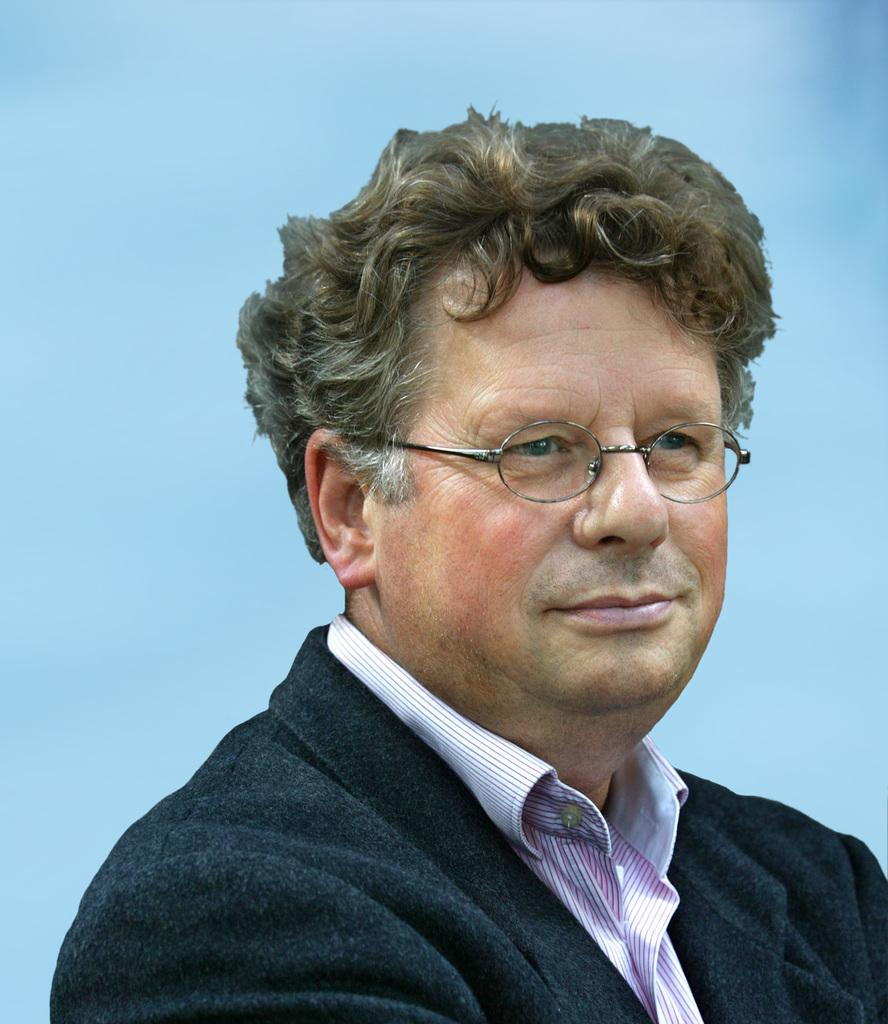What is present in the image? There is a man in the image. What is the man wearing on his upper body? The man is wearing a shirt and a black coat. What color is the background of the image? The background of the image is blue. What type of pet can be seen sitting next to the man in the image? There is no pet present in the image. What type of trousers is the man wearing in the image? The provided facts do not mention the type of trousers the man is wearing. Can you recite a verse that is written on the wall behind the man in the image? There is no verse visible in the image. 